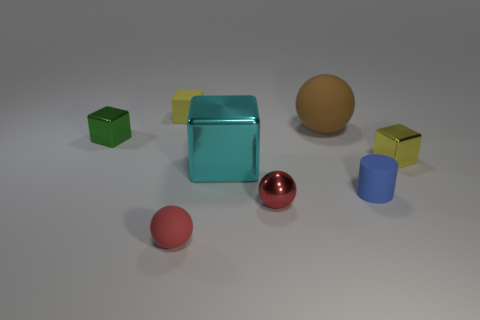What is the shape of the red rubber object? The shape of the red rubber object in the image is a sphere, or more commonly known as a ball. It has a smooth surface with a consistent curvature, reflecting light evenly due to its symmetrical shape. 